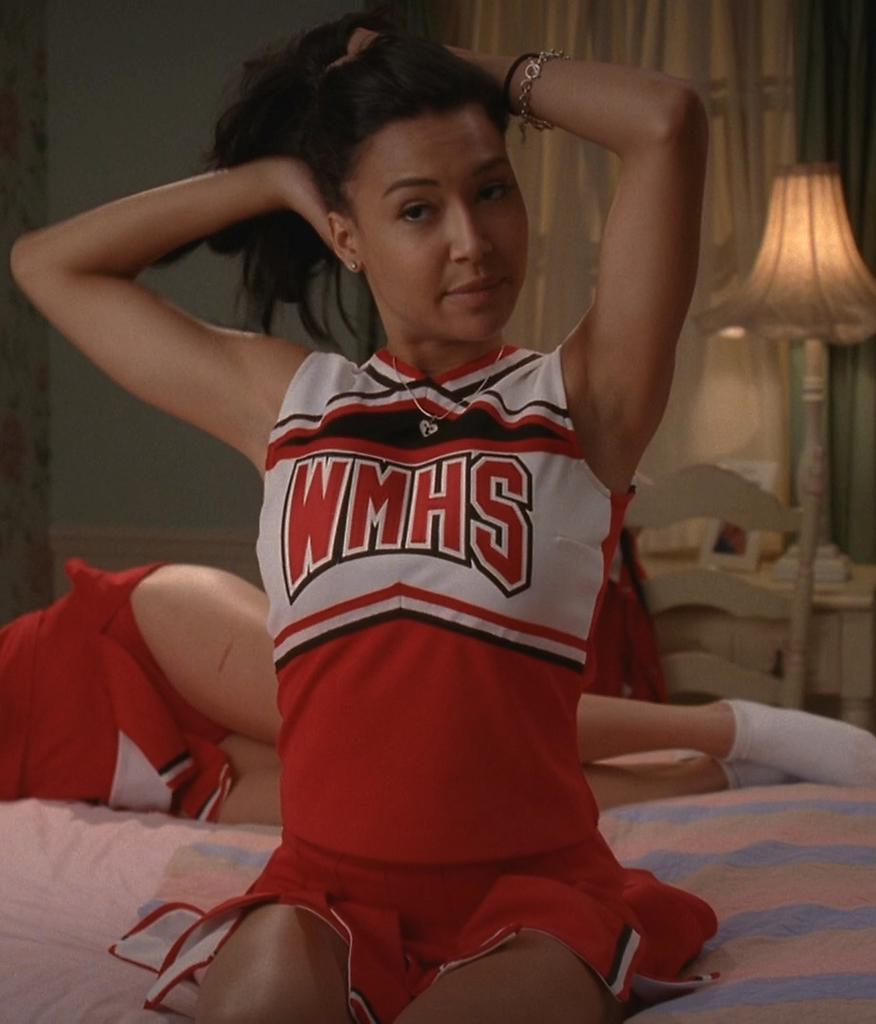<image>
Render a clear and concise summary of the photo. a lady with the name WMHS on her jersey 